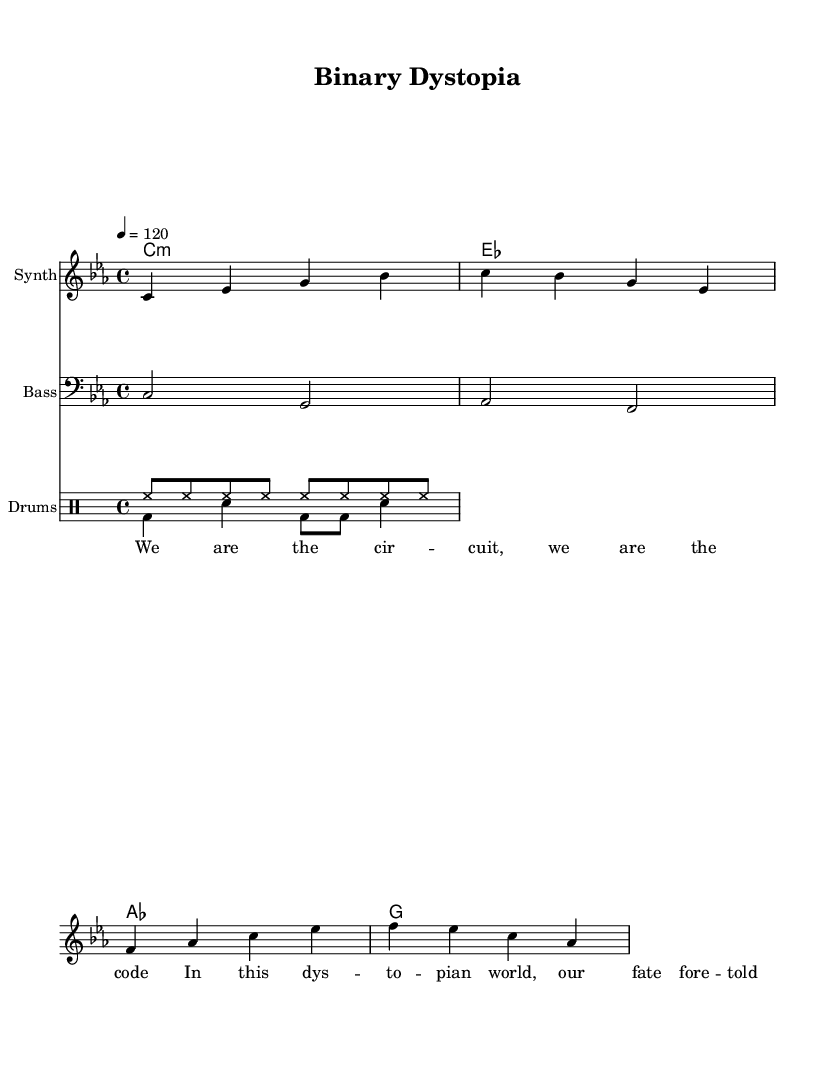What is the key signature of this music? The key signature indicates the presence of B flat and E flat, which is characteristic of C minor.
Answer: C minor What is the time signature of this piece? The time signature is found at the beginning of the score, showing that there are four beats per measure.
Answer: 4/4 What is the tempo marking for this piece? The tempo marking is indicated with a metronome marking of 120 beats per minute, shown at the start of the score.
Answer: 120 How many measures are in the melody? Counting the segments in the melody, there are a total of four measures indicated by the bars.
Answer: 4 What type of vocals are featured in the lyrics? The lyrics are set to robotic vocals, as indicated in the description of the song and the lyrics provided in lyric mode.
Answer: Robotic Which instrument is labeled as the melody in this arrangement? The staff labeled "Synth" holds the melody, which is indicated at the top of the staff in the score layout.
Answer: Synth What rhythmic pattern is used for the drums? The drums feature a specific combination of hi-hat and bass drum patterns repeated throughout the piece, shown in the drum staff.
Answer: hi-hat and bass drum pattern 